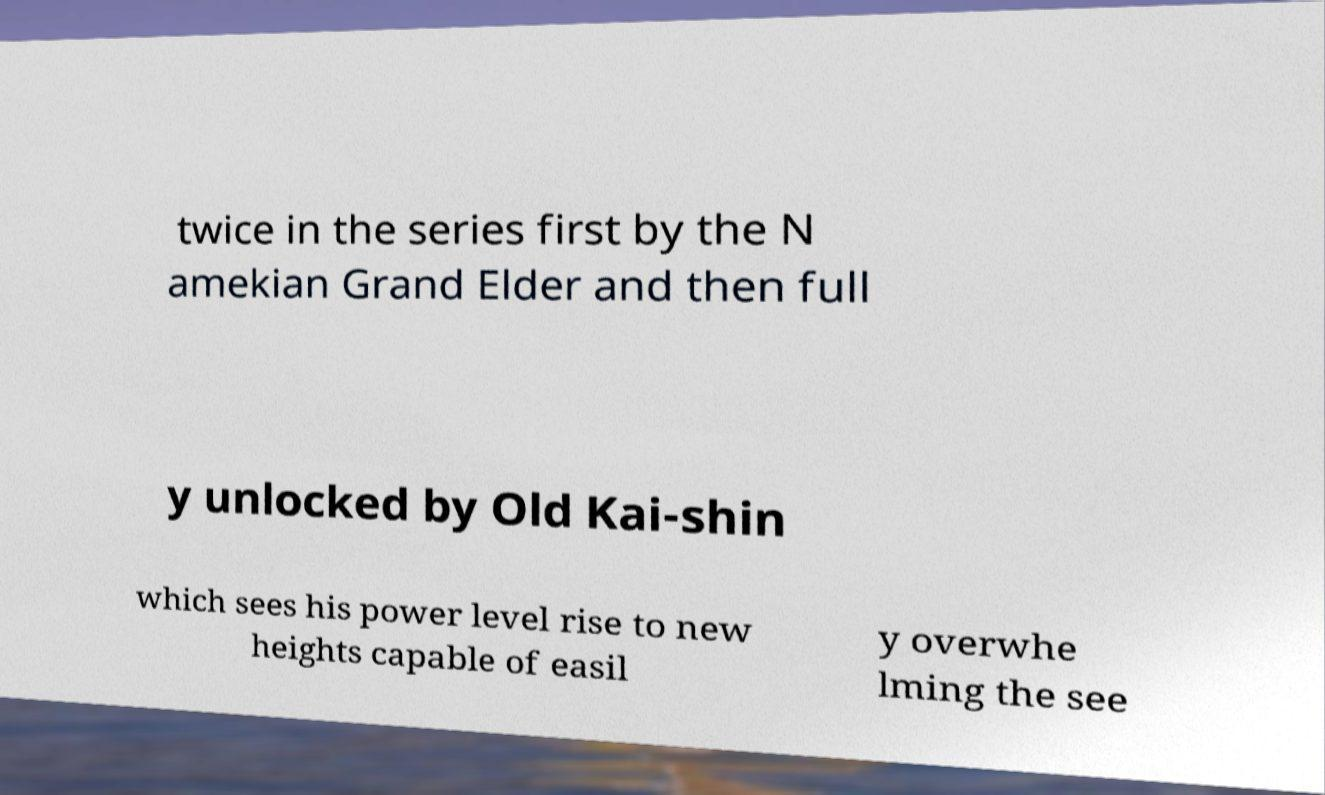I need the written content from this picture converted into text. Can you do that? twice in the series first by the N amekian Grand Elder and then full y unlocked by Old Kai-shin which sees his power level rise to new heights capable of easil y overwhe lming the see 